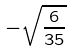<formula> <loc_0><loc_0><loc_500><loc_500>- \sqrt { \frac { 6 } { 3 5 } }</formula> 